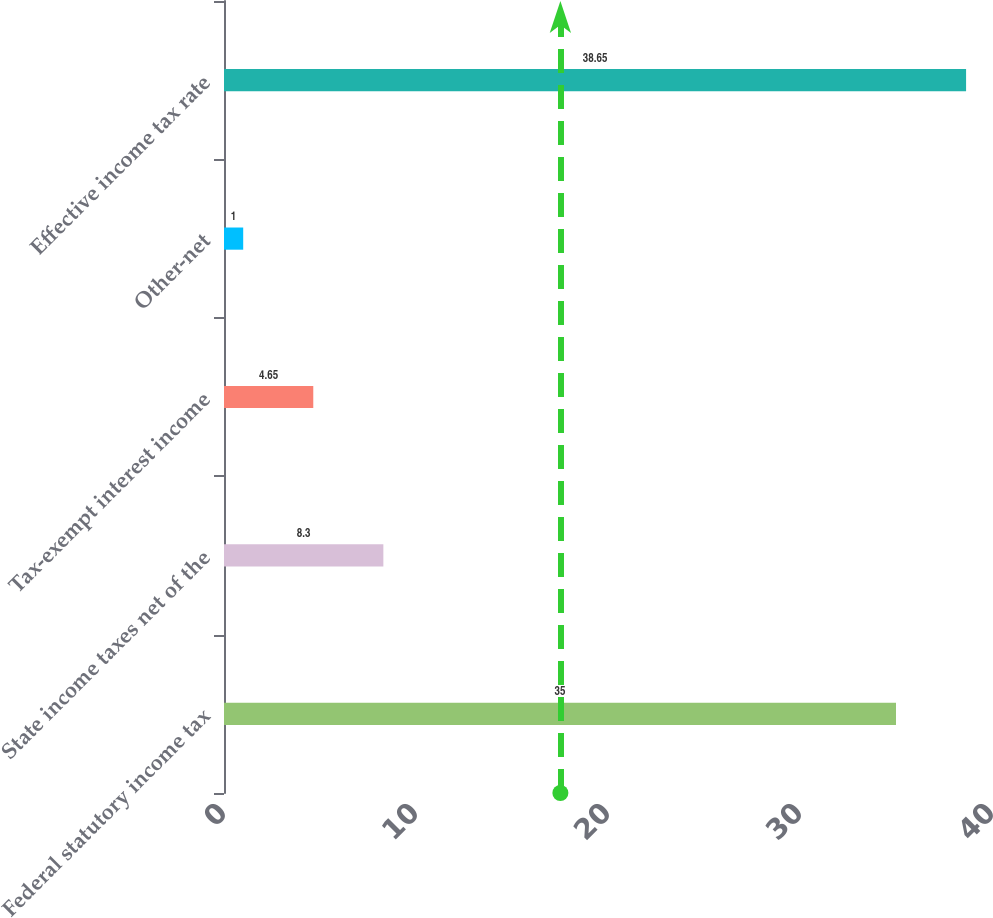Convert chart to OTSL. <chart><loc_0><loc_0><loc_500><loc_500><bar_chart><fcel>Federal statutory income tax<fcel>State income taxes net of the<fcel>Tax-exempt interest income<fcel>Other-net<fcel>Effective income tax rate<nl><fcel>35<fcel>8.3<fcel>4.65<fcel>1<fcel>38.65<nl></chart> 